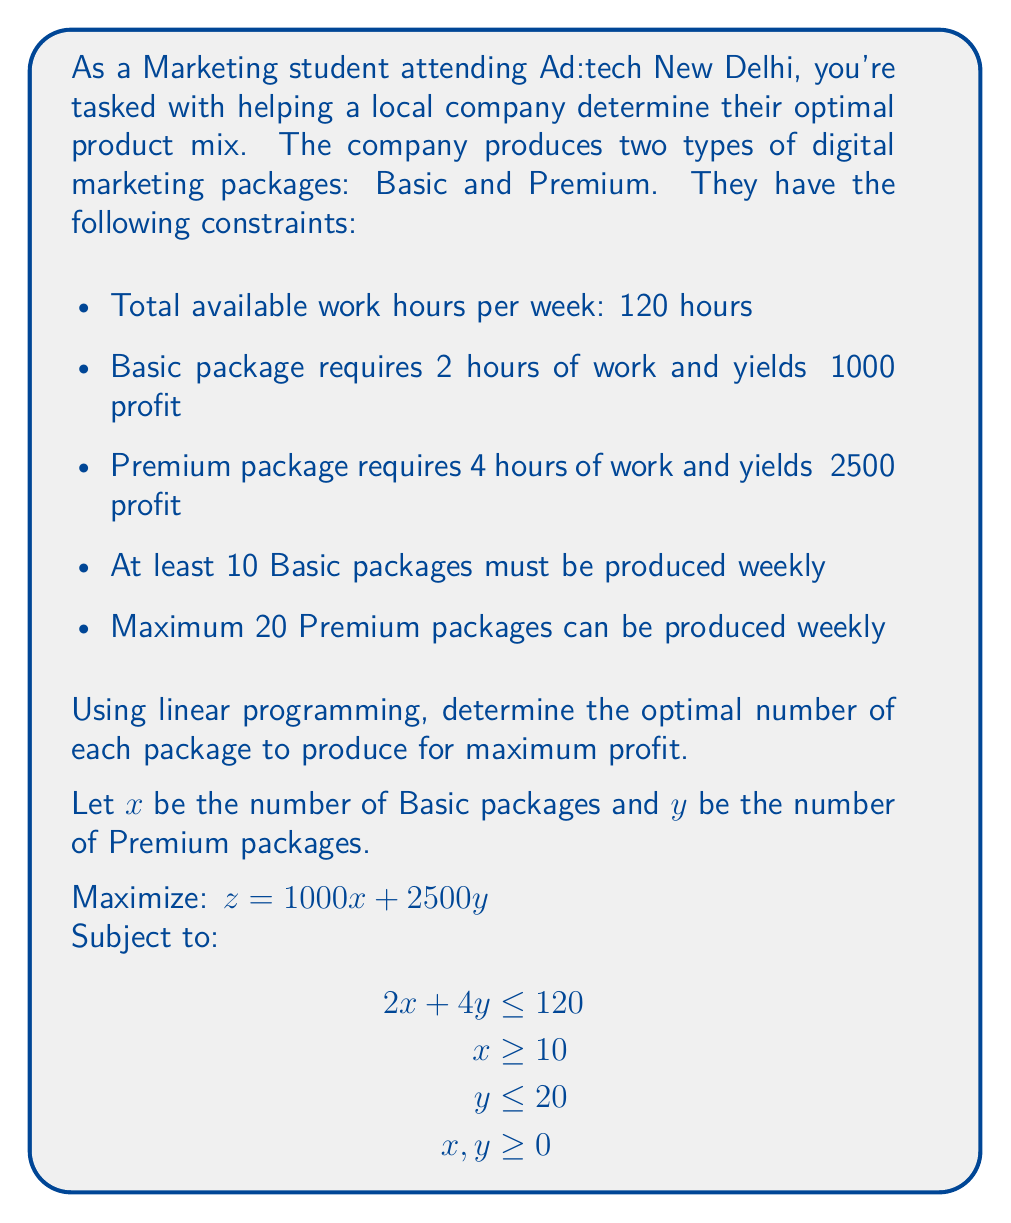Can you solve this math problem? Let's solve this step-by-step using the graphical method:

1) First, plot the constraints:
   - $2x + 4y = 120$ (resource constraint)
   - $x = 10$ (minimum Basic packages)
   - $y = 20$ (maximum Premium packages)

2) The feasible region is the area that satisfies all constraints.

3) Find the corner points of the feasible region:
   A: (10, 0)
   B: (10, 20)
   C: (30, 15)
   D: (60, 0)

4) Evaluate the objective function $z = 1000x + 2500y$ at each point:
   A: $z = 1000(10) + 2500(0) = 10,000$
   B: $z = 1000(10) + 2500(20) = 60,000$
   C: $z = 1000(30) + 2500(15) = 67,500$
   D: $z = 1000(60) + 2500(0) = 60,000$

5) The maximum value occurs at point C (30, 15).

Therefore, the optimal solution is to produce 30 Basic packages and 15 Premium packages, yielding a maximum profit of ₹67,500.
Answer: 30 Basic packages, 15 Premium packages; Maximum profit: ₹67,500 